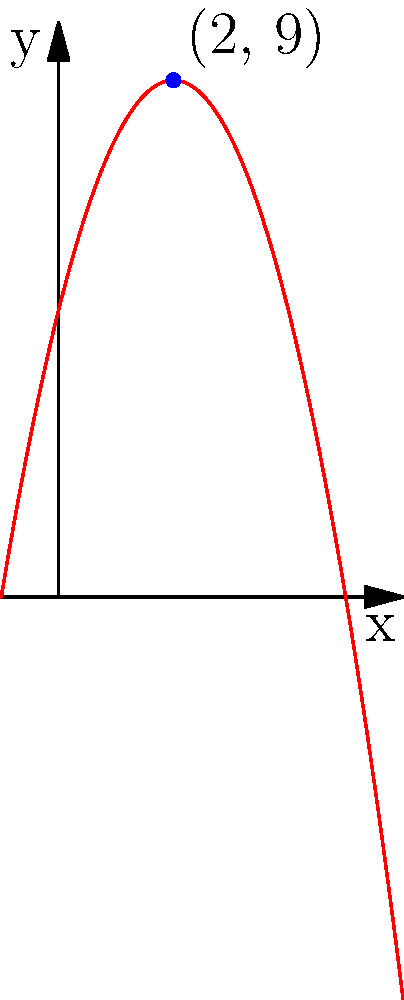Farmer Petro from Sukhovolia village is planning to fence off a rectangular area for his potato crop. He models the yield of potatoes (in kilograms) as a function of the width of the field (in meters) using the equation $f(x) = -x^2 + 4x + 5$, where $x$ is the width. Based on the graph of this function, what is the maximum yield of potatoes Farmer Petro can expect? To find the maximum yield, we need to identify the highest point on the graph. This point represents the vertex of the parabola, which is the maximum point for this quadratic function.

Steps to solve:
1. Observe the graph: The parabola opens downward (negative coefficient of $x^2$).
2. Locate the vertex: The highest point on the graph is clearly visible.
3. Read the coordinates: The blue dot on the graph represents the vertex.
4. Interpret the coordinates: The x-coordinate (2) represents the optimal width, and the y-coordinate (9) represents the maximum yield.

Therefore, the maximum yield Farmer Petro can expect is 9 kilograms of potatoes.
Answer: 9 kilograms 